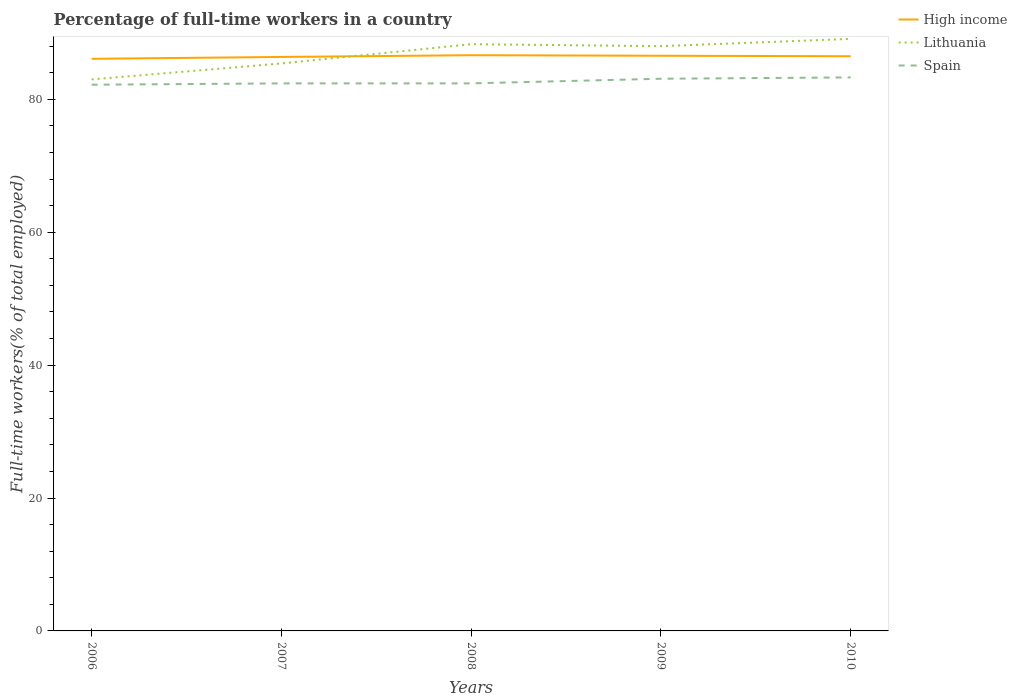In which year was the percentage of full-time workers in Spain maximum?
Your answer should be compact. 2006. What is the total percentage of full-time workers in Lithuania in the graph?
Ensure brevity in your answer.  -3.7. What is the difference between the highest and the second highest percentage of full-time workers in Lithuania?
Your response must be concise. 6.1. How many years are there in the graph?
Give a very brief answer. 5. What is the difference between two consecutive major ticks on the Y-axis?
Your response must be concise. 20. Does the graph contain any zero values?
Provide a succinct answer. No. Does the graph contain grids?
Provide a succinct answer. No. How many legend labels are there?
Keep it short and to the point. 3. How are the legend labels stacked?
Provide a short and direct response. Vertical. What is the title of the graph?
Keep it short and to the point. Percentage of full-time workers in a country. What is the label or title of the X-axis?
Make the answer very short. Years. What is the label or title of the Y-axis?
Provide a short and direct response. Full-time workers(% of total employed). What is the Full-time workers(% of total employed) in High income in 2006?
Offer a terse response. 86.1. What is the Full-time workers(% of total employed) of Lithuania in 2006?
Keep it short and to the point. 83. What is the Full-time workers(% of total employed) in Spain in 2006?
Your answer should be compact. 82.2. What is the Full-time workers(% of total employed) of High income in 2007?
Ensure brevity in your answer.  86.38. What is the Full-time workers(% of total employed) in Lithuania in 2007?
Your answer should be very brief. 85.4. What is the Full-time workers(% of total employed) in Spain in 2007?
Offer a terse response. 82.4. What is the Full-time workers(% of total employed) in High income in 2008?
Offer a very short reply. 86.64. What is the Full-time workers(% of total employed) in Lithuania in 2008?
Your answer should be very brief. 88.3. What is the Full-time workers(% of total employed) of Spain in 2008?
Provide a short and direct response. 82.4. What is the Full-time workers(% of total employed) of High income in 2009?
Your answer should be very brief. 86.56. What is the Full-time workers(% of total employed) of Spain in 2009?
Your answer should be very brief. 83.1. What is the Full-time workers(% of total employed) in High income in 2010?
Your answer should be compact. 86.49. What is the Full-time workers(% of total employed) in Lithuania in 2010?
Your response must be concise. 89.1. What is the Full-time workers(% of total employed) of Spain in 2010?
Provide a short and direct response. 83.3. Across all years, what is the maximum Full-time workers(% of total employed) in High income?
Offer a very short reply. 86.64. Across all years, what is the maximum Full-time workers(% of total employed) of Lithuania?
Your answer should be very brief. 89.1. Across all years, what is the maximum Full-time workers(% of total employed) of Spain?
Your response must be concise. 83.3. Across all years, what is the minimum Full-time workers(% of total employed) of High income?
Provide a short and direct response. 86.1. Across all years, what is the minimum Full-time workers(% of total employed) in Lithuania?
Offer a terse response. 83. Across all years, what is the minimum Full-time workers(% of total employed) in Spain?
Provide a succinct answer. 82.2. What is the total Full-time workers(% of total employed) in High income in the graph?
Offer a very short reply. 432.16. What is the total Full-time workers(% of total employed) in Lithuania in the graph?
Ensure brevity in your answer.  433.8. What is the total Full-time workers(% of total employed) in Spain in the graph?
Offer a very short reply. 413.4. What is the difference between the Full-time workers(% of total employed) of High income in 2006 and that in 2007?
Ensure brevity in your answer.  -0.28. What is the difference between the Full-time workers(% of total employed) of Lithuania in 2006 and that in 2007?
Ensure brevity in your answer.  -2.4. What is the difference between the Full-time workers(% of total employed) of Spain in 2006 and that in 2007?
Offer a very short reply. -0.2. What is the difference between the Full-time workers(% of total employed) in High income in 2006 and that in 2008?
Your answer should be compact. -0.54. What is the difference between the Full-time workers(% of total employed) of Lithuania in 2006 and that in 2008?
Your response must be concise. -5.3. What is the difference between the Full-time workers(% of total employed) in Spain in 2006 and that in 2008?
Offer a very short reply. -0.2. What is the difference between the Full-time workers(% of total employed) of High income in 2006 and that in 2009?
Give a very brief answer. -0.46. What is the difference between the Full-time workers(% of total employed) in Lithuania in 2006 and that in 2009?
Provide a succinct answer. -5. What is the difference between the Full-time workers(% of total employed) in High income in 2006 and that in 2010?
Provide a short and direct response. -0.39. What is the difference between the Full-time workers(% of total employed) of Lithuania in 2006 and that in 2010?
Offer a terse response. -6.1. What is the difference between the Full-time workers(% of total employed) of Spain in 2006 and that in 2010?
Provide a short and direct response. -1.1. What is the difference between the Full-time workers(% of total employed) in High income in 2007 and that in 2008?
Give a very brief answer. -0.26. What is the difference between the Full-time workers(% of total employed) in Lithuania in 2007 and that in 2008?
Provide a short and direct response. -2.9. What is the difference between the Full-time workers(% of total employed) of High income in 2007 and that in 2009?
Give a very brief answer. -0.18. What is the difference between the Full-time workers(% of total employed) in Spain in 2007 and that in 2009?
Make the answer very short. -0.7. What is the difference between the Full-time workers(% of total employed) in High income in 2007 and that in 2010?
Offer a very short reply. -0.11. What is the difference between the Full-time workers(% of total employed) in High income in 2008 and that in 2009?
Provide a short and direct response. 0.08. What is the difference between the Full-time workers(% of total employed) of High income in 2008 and that in 2010?
Give a very brief answer. 0.16. What is the difference between the Full-time workers(% of total employed) in Lithuania in 2008 and that in 2010?
Ensure brevity in your answer.  -0.8. What is the difference between the Full-time workers(% of total employed) of Spain in 2008 and that in 2010?
Your answer should be compact. -0.9. What is the difference between the Full-time workers(% of total employed) in High income in 2009 and that in 2010?
Make the answer very short. 0.07. What is the difference between the Full-time workers(% of total employed) in Lithuania in 2009 and that in 2010?
Provide a short and direct response. -1.1. What is the difference between the Full-time workers(% of total employed) of High income in 2006 and the Full-time workers(% of total employed) of Lithuania in 2007?
Ensure brevity in your answer.  0.7. What is the difference between the Full-time workers(% of total employed) in High income in 2006 and the Full-time workers(% of total employed) in Spain in 2007?
Your answer should be compact. 3.7. What is the difference between the Full-time workers(% of total employed) of Lithuania in 2006 and the Full-time workers(% of total employed) of Spain in 2007?
Ensure brevity in your answer.  0.6. What is the difference between the Full-time workers(% of total employed) in High income in 2006 and the Full-time workers(% of total employed) in Lithuania in 2008?
Your answer should be compact. -2.2. What is the difference between the Full-time workers(% of total employed) in High income in 2006 and the Full-time workers(% of total employed) in Spain in 2008?
Provide a short and direct response. 3.7. What is the difference between the Full-time workers(% of total employed) of Lithuania in 2006 and the Full-time workers(% of total employed) of Spain in 2008?
Offer a very short reply. 0.6. What is the difference between the Full-time workers(% of total employed) of High income in 2006 and the Full-time workers(% of total employed) of Lithuania in 2009?
Ensure brevity in your answer.  -1.9. What is the difference between the Full-time workers(% of total employed) of High income in 2006 and the Full-time workers(% of total employed) of Spain in 2009?
Your answer should be compact. 3. What is the difference between the Full-time workers(% of total employed) of High income in 2006 and the Full-time workers(% of total employed) of Lithuania in 2010?
Provide a succinct answer. -3. What is the difference between the Full-time workers(% of total employed) of High income in 2006 and the Full-time workers(% of total employed) of Spain in 2010?
Your answer should be compact. 2.8. What is the difference between the Full-time workers(% of total employed) of High income in 2007 and the Full-time workers(% of total employed) of Lithuania in 2008?
Give a very brief answer. -1.92. What is the difference between the Full-time workers(% of total employed) of High income in 2007 and the Full-time workers(% of total employed) of Spain in 2008?
Provide a succinct answer. 3.98. What is the difference between the Full-time workers(% of total employed) of Lithuania in 2007 and the Full-time workers(% of total employed) of Spain in 2008?
Your response must be concise. 3. What is the difference between the Full-time workers(% of total employed) in High income in 2007 and the Full-time workers(% of total employed) in Lithuania in 2009?
Offer a terse response. -1.62. What is the difference between the Full-time workers(% of total employed) in High income in 2007 and the Full-time workers(% of total employed) in Spain in 2009?
Offer a very short reply. 3.28. What is the difference between the Full-time workers(% of total employed) in Lithuania in 2007 and the Full-time workers(% of total employed) in Spain in 2009?
Your response must be concise. 2.3. What is the difference between the Full-time workers(% of total employed) in High income in 2007 and the Full-time workers(% of total employed) in Lithuania in 2010?
Your answer should be compact. -2.72. What is the difference between the Full-time workers(% of total employed) of High income in 2007 and the Full-time workers(% of total employed) of Spain in 2010?
Your answer should be compact. 3.08. What is the difference between the Full-time workers(% of total employed) in Lithuania in 2007 and the Full-time workers(% of total employed) in Spain in 2010?
Give a very brief answer. 2.1. What is the difference between the Full-time workers(% of total employed) in High income in 2008 and the Full-time workers(% of total employed) in Lithuania in 2009?
Your answer should be very brief. -1.36. What is the difference between the Full-time workers(% of total employed) in High income in 2008 and the Full-time workers(% of total employed) in Spain in 2009?
Make the answer very short. 3.54. What is the difference between the Full-time workers(% of total employed) of High income in 2008 and the Full-time workers(% of total employed) of Lithuania in 2010?
Your response must be concise. -2.46. What is the difference between the Full-time workers(% of total employed) of High income in 2008 and the Full-time workers(% of total employed) of Spain in 2010?
Your response must be concise. 3.34. What is the difference between the Full-time workers(% of total employed) in Lithuania in 2008 and the Full-time workers(% of total employed) in Spain in 2010?
Give a very brief answer. 5. What is the difference between the Full-time workers(% of total employed) of High income in 2009 and the Full-time workers(% of total employed) of Lithuania in 2010?
Make the answer very short. -2.54. What is the difference between the Full-time workers(% of total employed) of High income in 2009 and the Full-time workers(% of total employed) of Spain in 2010?
Keep it short and to the point. 3.26. What is the average Full-time workers(% of total employed) of High income per year?
Give a very brief answer. 86.43. What is the average Full-time workers(% of total employed) in Lithuania per year?
Give a very brief answer. 86.76. What is the average Full-time workers(% of total employed) in Spain per year?
Keep it short and to the point. 82.68. In the year 2006, what is the difference between the Full-time workers(% of total employed) in High income and Full-time workers(% of total employed) in Lithuania?
Your answer should be compact. 3.1. In the year 2006, what is the difference between the Full-time workers(% of total employed) of High income and Full-time workers(% of total employed) of Spain?
Your answer should be compact. 3.9. In the year 2007, what is the difference between the Full-time workers(% of total employed) in High income and Full-time workers(% of total employed) in Lithuania?
Offer a very short reply. 0.98. In the year 2007, what is the difference between the Full-time workers(% of total employed) of High income and Full-time workers(% of total employed) of Spain?
Your response must be concise. 3.98. In the year 2007, what is the difference between the Full-time workers(% of total employed) of Lithuania and Full-time workers(% of total employed) of Spain?
Keep it short and to the point. 3. In the year 2008, what is the difference between the Full-time workers(% of total employed) of High income and Full-time workers(% of total employed) of Lithuania?
Ensure brevity in your answer.  -1.66. In the year 2008, what is the difference between the Full-time workers(% of total employed) in High income and Full-time workers(% of total employed) in Spain?
Your answer should be very brief. 4.24. In the year 2009, what is the difference between the Full-time workers(% of total employed) of High income and Full-time workers(% of total employed) of Lithuania?
Offer a very short reply. -1.44. In the year 2009, what is the difference between the Full-time workers(% of total employed) of High income and Full-time workers(% of total employed) of Spain?
Offer a very short reply. 3.46. In the year 2009, what is the difference between the Full-time workers(% of total employed) of Lithuania and Full-time workers(% of total employed) of Spain?
Your response must be concise. 4.9. In the year 2010, what is the difference between the Full-time workers(% of total employed) in High income and Full-time workers(% of total employed) in Lithuania?
Keep it short and to the point. -2.61. In the year 2010, what is the difference between the Full-time workers(% of total employed) of High income and Full-time workers(% of total employed) of Spain?
Offer a very short reply. 3.19. What is the ratio of the Full-time workers(% of total employed) in High income in 2006 to that in 2007?
Your response must be concise. 1. What is the ratio of the Full-time workers(% of total employed) of Lithuania in 2006 to that in 2007?
Your answer should be very brief. 0.97. What is the ratio of the Full-time workers(% of total employed) of Spain in 2006 to that in 2007?
Provide a succinct answer. 1. What is the ratio of the Full-time workers(% of total employed) in High income in 2006 to that in 2008?
Offer a very short reply. 0.99. What is the ratio of the Full-time workers(% of total employed) in Spain in 2006 to that in 2008?
Keep it short and to the point. 1. What is the ratio of the Full-time workers(% of total employed) of High income in 2006 to that in 2009?
Provide a succinct answer. 0.99. What is the ratio of the Full-time workers(% of total employed) of Lithuania in 2006 to that in 2009?
Give a very brief answer. 0.94. What is the ratio of the Full-time workers(% of total employed) in High income in 2006 to that in 2010?
Make the answer very short. 1. What is the ratio of the Full-time workers(% of total employed) in Lithuania in 2006 to that in 2010?
Your answer should be very brief. 0.93. What is the ratio of the Full-time workers(% of total employed) in Lithuania in 2007 to that in 2008?
Make the answer very short. 0.97. What is the ratio of the Full-time workers(% of total employed) of High income in 2007 to that in 2009?
Keep it short and to the point. 1. What is the ratio of the Full-time workers(% of total employed) of Lithuania in 2007 to that in 2009?
Make the answer very short. 0.97. What is the ratio of the Full-time workers(% of total employed) in High income in 2007 to that in 2010?
Keep it short and to the point. 1. What is the ratio of the Full-time workers(% of total employed) in Lithuania in 2007 to that in 2010?
Ensure brevity in your answer.  0.96. What is the ratio of the Full-time workers(% of total employed) of Spain in 2007 to that in 2010?
Keep it short and to the point. 0.99. What is the ratio of the Full-time workers(% of total employed) of High income in 2008 to that in 2009?
Give a very brief answer. 1. What is the ratio of the Full-time workers(% of total employed) of Spain in 2008 to that in 2009?
Your response must be concise. 0.99. What is the ratio of the Full-time workers(% of total employed) of Lithuania in 2008 to that in 2010?
Your answer should be very brief. 0.99. What is the ratio of the Full-time workers(% of total employed) in High income in 2009 to that in 2010?
Your answer should be compact. 1. What is the ratio of the Full-time workers(% of total employed) in Lithuania in 2009 to that in 2010?
Keep it short and to the point. 0.99. What is the ratio of the Full-time workers(% of total employed) in Spain in 2009 to that in 2010?
Offer a very short reply. 1. What is the difference between the highest and the second highest Full-time workers(% of total employed) in High income?
Your answer should be compact. 0.08. What is the difference between the highest and the second highest Full-time workers(% of total employed) of Spain?
Offer a terse response. 0.2. What is the difference between the highest and the lowest Full-time workers(% of total employed) in High income?
Your response must be concise. 0.54. What is the difference between the highest and the lowest Full-time workers(% of total employed) of Lithuania?
Offer a very short reply. 6.1. 